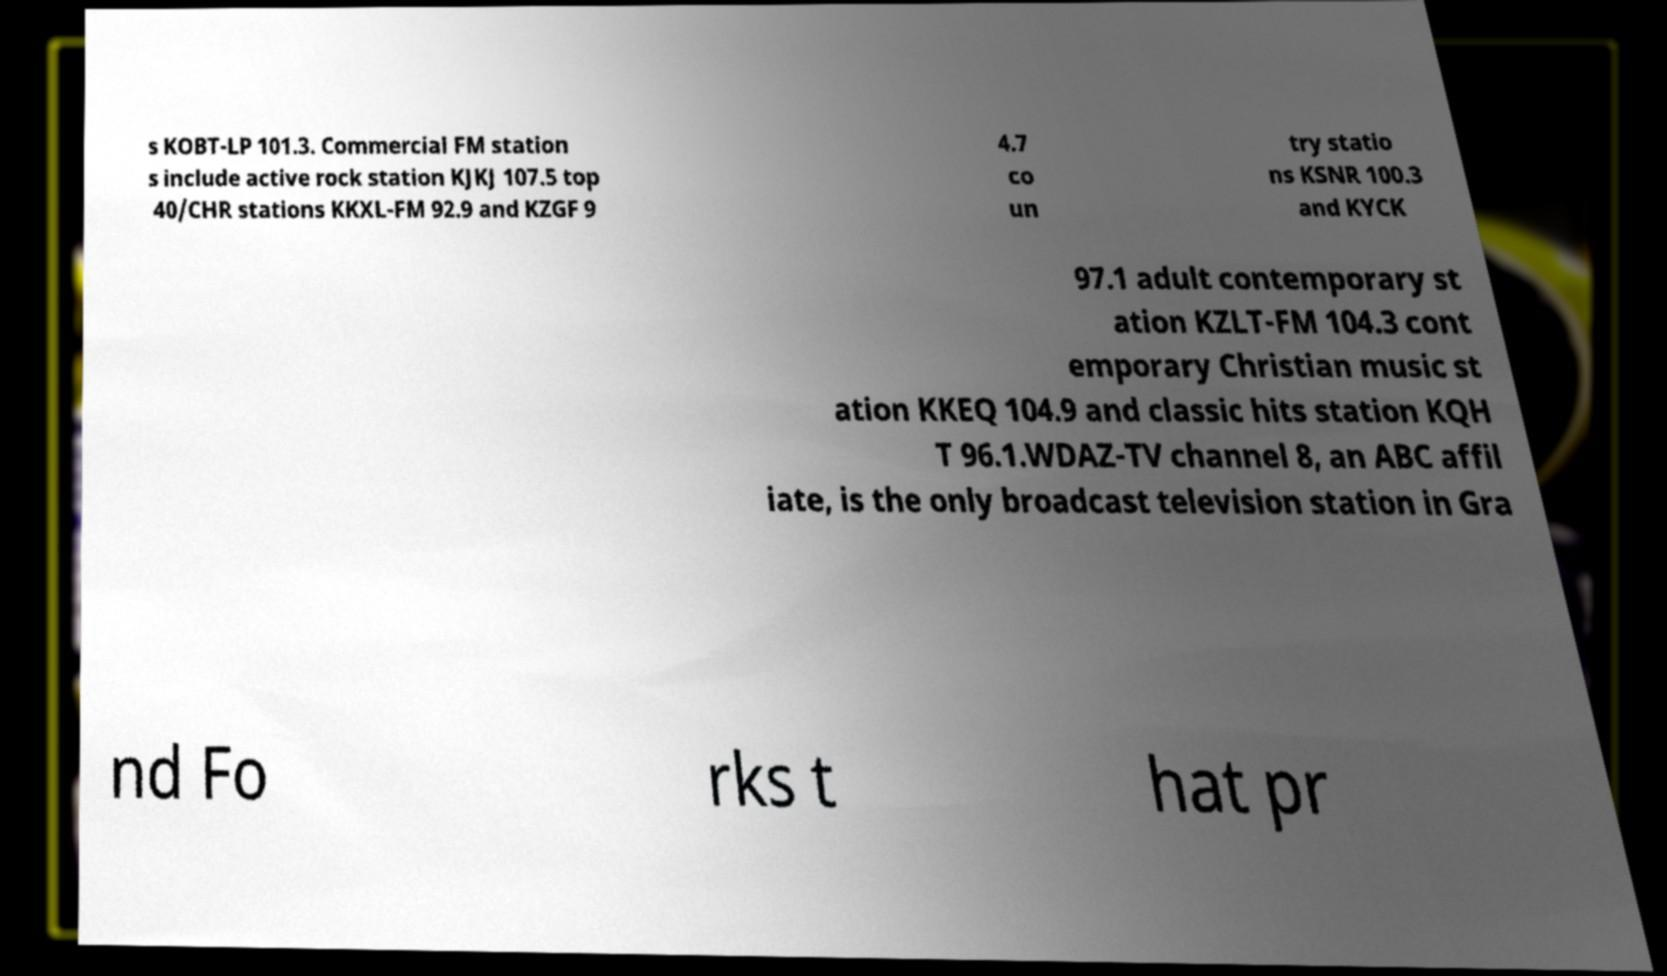There's text embedded in this image that I need extracted. Can you transcribe it verbatim? s KOBT-LP 101.3. Commercial FM station s include active rock station KJKJ 107.5 top 40/CHR stations KKXL-FM 92.9 and KZGF 9 4.7 co un try statio ns KSNR 100.3 and KYCK 97.1 adult contemporary st ation KZLT-FM 104.3 cont emporary Christian music st ation KKEQ 104.9 and classic hits station KQH T 96.1.WDAZ-TV channel 8, an ABC affil iate, is the only broadcast television station in Gra nd Fo rks t hat pr 